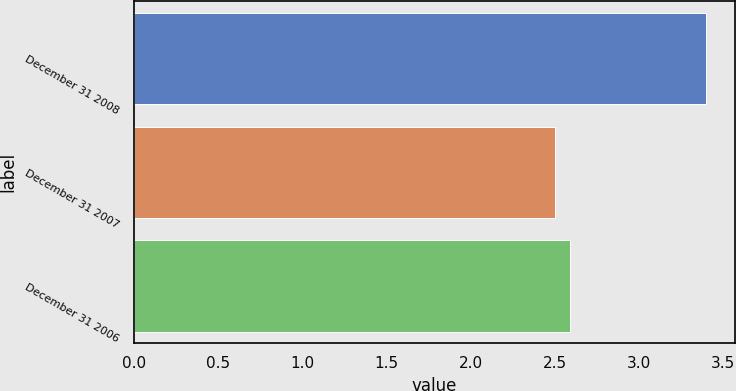<chart> <loc_0><loc_0><loc_500><loc_500><bar_chart><fcel>December 31 2008<fcel>December 31 2007<fcel>December 31 2006<nl><fcel>3.4<fcel>2.5<fcel>2.59<nl></chart> 